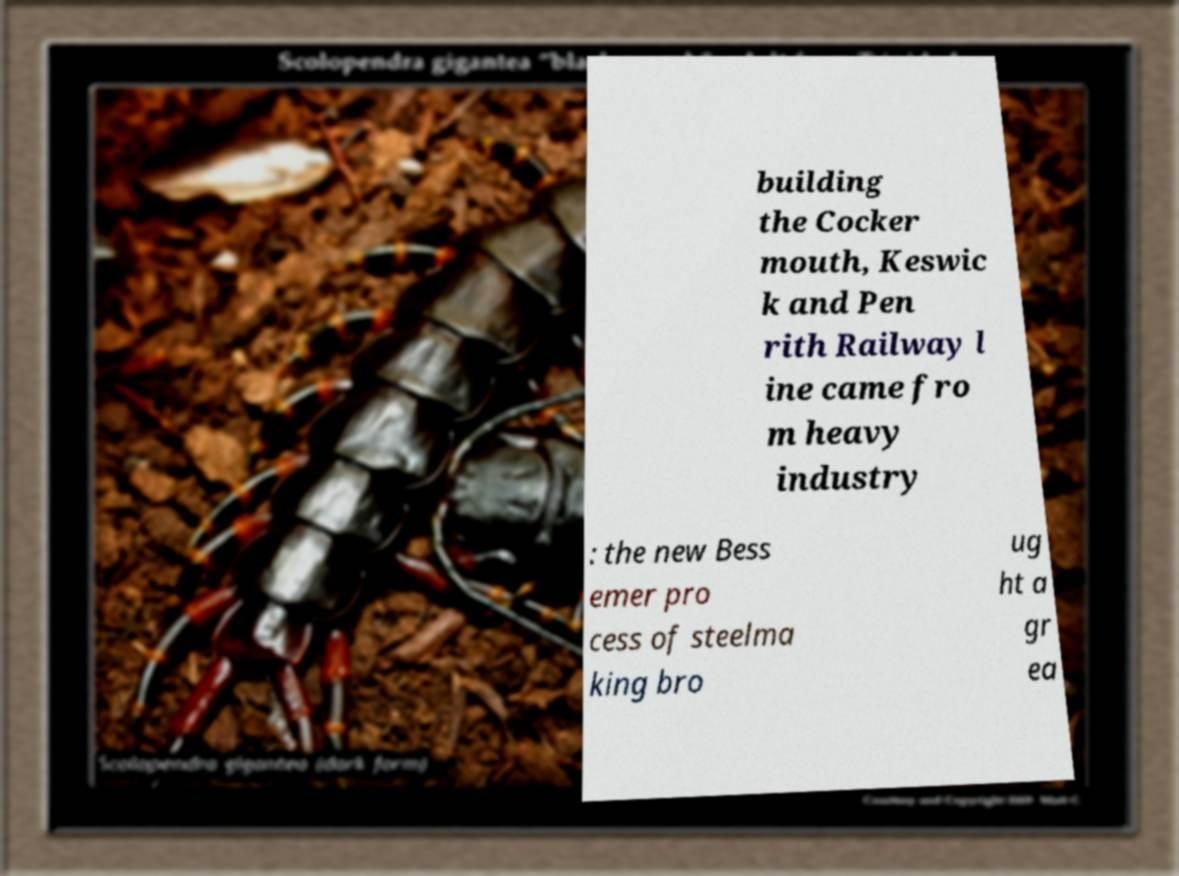Can you read and provide the text displayed in the image?This photo seems to have some interesting text. Can you extract and type it out for me? building the Cocker mouth, Keswic k and Pen rith Railway l ine came fro m heavy industry : the new Bess emer pro cess of steelma king bro ug ht a gr ea 